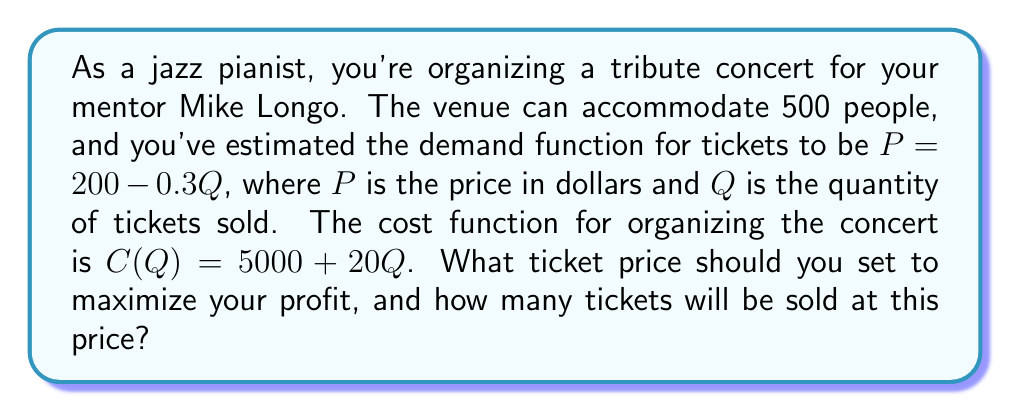Could you help me with this problem? To solve this problem, we need to follow these steps:

1) First, let's derive the revenue function. Revenue is price multiplied by quantity:
   $R(Q) = P \cdot Q = (200 - 0.3Q) \cdot Q = 200Q - 0.3Q^2$

2) The profit function is revenue minus cost:
   $\Pi(Q) = R(Q) - C(Q) = (200Q - 0.3Q^2) - (5000 + 20Q) = 180Q - 0.3Q^2 - 5000$

3) To find the maximum profit, we need to find where the derivative of the profit function equals zero:
   $\frac{d\Pi}{dQ} = 180 - 0.6Q = 0$

4) Solving this equation:
   $180 - 0.6Q = 0$
   $-0.6Q = -180$
   $Q = 300$

5) To confirm this is a maximum, we can check that the second derivative is negative:
   $\frac{d^2\Pi}{dQ^2} = -0.6 < 0$

6) Now that we know the optimal quantity, we can find the optimal price by plugging this quantity into our demand function:
   $P = 200 - 0.3(300) = 200 - 90 = 110$

7) To double-check our work, we can calculate the profit at this price and quantity:
   $\Pi(300) = 180(300) - 0.3(300)^2 - 5000 = 54000 - 27000 - 5000 = 22000$

Therefore, the optimal strategy is to price tickets at $110 each, which will result in selling 300 tickets.
Answer: The optimal ticket price is $110, and 300 tickets will be sold at this price. 